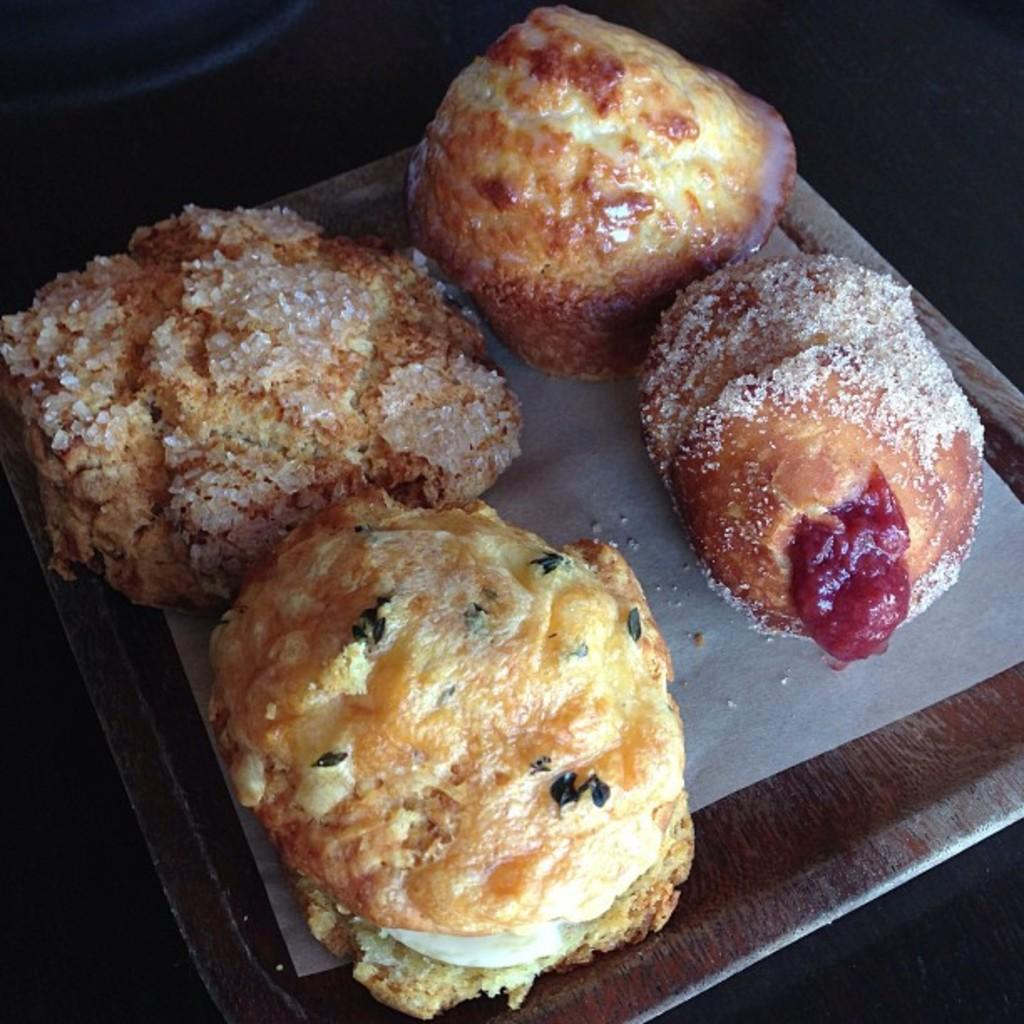What is the main subject of the image? There is a food item on a plate in the image. Can you tell me how many volleyballs are visible in the image? There are no volleyballs present in the image. What type of fowl can be seen in the image? There is no fowl present in the image. 